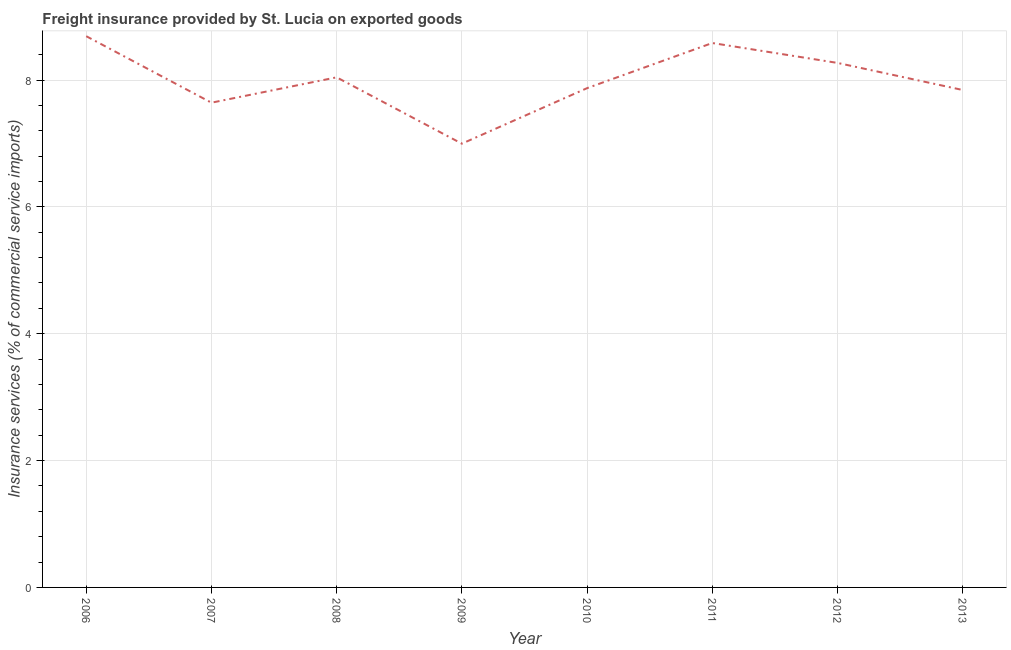What is the freight insurance in 2007?
Give a very brief answer. 7.64. Across all years, what is the maximum freight insurance?
Make the answer very short. 8.69. Across all years, what is the minimum freight insurance?
Your answer should be compact. 7. In which year was the freight insurance maximum?
Your answer should be very brief. 2006. What is the sum of the freight insurance?
Your answer should be very brief. 63.94. What is the difference between the freight insurance in 2006 and 2008?
Your answer should be compact. 0.65. What is the average freight insurance per year?
Give a very brief answer. 7.99. What is the median freight insurance?
Provide a short and direct response. 7.96. In how many years, is the freight insurance greater than 6.8 %?
Your response must be concise. 8. What is the ratio of the freight insurance in 2008 to that in 2013?
Your answer should be compact. 1.03. Is the difference between the freight insurance in 2010 and 2011 greater than the difference between any two years?
Make the answer very short. No. What is the difference between the highest and the second highest freight insurance?
Offer a very short reply. 0.11. Is the sum of the freight insurance in 2008 and 2009 greater than the maximum freight insurance across all years?
Your answer should be very brief. Yes. What is the difference between the highest and the lowest freight insurance?
Offer a terse response. 1.69. Does the freight insurance monotonically increase over the years?
Offer a very short reply. No. How many lines are there?
Provide a succinct answer. 1. How many years are there in the graph?
Your answer should be compact. 8. What is the title of the graph?
Make the answer very short. Freight insurance provided by St. Lucia on exported goods . What is the label or title of the X-axis?
Provide a succinct answer. Year. What is the label or title of the Y-axis?
Offer a terse response. Insurance services (% of commercial service imports). What is the Insurance services (% of commercial service imports) of 2006?
Provide a succinct answer. 8.69. What is the Insurance services (% of commercial service imports) in 2007?
Provide a succinct answer. 7.64. What is the Insurance services (% of commercial service imports) of 2008?
Ensure brevity in your answer.  8.04. What is the Insurance services (% of commercial service imports) in 2009?
Provide a succinct answer. 7. What is the Insurance services (% of commercial service imports) in 2010?
Ensure brevity in your answer.  7.87. What is the Insurance services (% of commercial service imports) of 2011?
Offer a terse response. 8.58. What is the Insurance services (% of commercial service imports) in 2012?
Make the answer very short. 8.27. What is the Insurance services (% of commercial service imports) in 2013?
Keep it short and to the point. 7.84. What is the difference between the Insurance services (% of commercial service imports) in 2006 and 2007?
Give a very brief answer. 1.05. What is the difference between the Insurance services (% of commercial service imports) in 2006 and 2008?
Offer a very short reply. 0.65. What is the difference between the Insurance services (% of commercial service imports) in 2006 and 2009?
Your answer should be compact. 1.69. What is the difference between the Insurance services (% of commercial service imports) in 2006 and 2010?
Provide a succinct answer. 0.82. What is the difference between the Insurance services (% of commercial service imports) in 2006 and 2011?
Keep it short and to the point. 0.11. What is the difference between the Insurance services (% of commercial service imports) in 2006 and 2012?
Your answer should be very brief. 0.42. What is the difference between the Insurance services (% of commercial service imports) in 2006 and 2013?
Ensure brevity in your answer.  0.85. What is the difference between the Insurance services (% of commercial service imports) in 2007 and 2008?
Your answer should be compact. -0.4. What is the difference between the Insurance services (% of commercial service imports) in 2007 and 2009?
Provide a short and direct response. 0.65. What is the difference between the Insurance services (% of commercial service imports) in 2007 and 2010?
Offer a terse response. -0.23. What is the difference between the Insurance services (% of commercial service imports) in 2007 and 2011?
Your response must be concise. -0.94. What is the difference between the Insurance services (% of commercial service imports) in 2007 and 2012?
Your response must be concise. -0.63. What is the difference between the Insurance services (% of commercial service imports) in 2007 and 2013?
Offer a very short reply. -0.2. What is the difference between the Insurance services (% of commercial service imports) in 2008 and 2009?
Give a very brief answer. 1.05. What is the difference between the Insurance services (% of commercial service imports) in 2008 and 2010?
Offer a very short reply. 0.17. What is the difference between the Insurance services (% of commercial service imports) in 2008 and 2011?
Offer a very short reply. -0.54. What is the difference between the Insurance services (% of commercial service imports) in 2008 and 2012?
Keep it short and to the point. -0.23. What is the difference between the Insurance services (% of commercial service imports) in 2008 and 2013?
Offer a very short reply. 0.2. What is the difference between the Insurance services (% of commercial service imports) in 2009 and 2010?
Offer a terse response. -0.88. What is the difference between the Insurance services (% of commercial service imports) in 2009 and 2011?
Provide a short and direct response. -1.59. What is the difference between the Insurance services (% of commercial service imports) in 2009 and 2012?
Provide a succinct answer. -1.27. What is the difference between the Insurance services (% of commercial service imports) in 2009 and 2013?
Your answer should be very brief. -0.85. What is the difference between the Insurance services (% of commercial service imports) in 2010 and 2011?
Provide a short and direct response. -0.71. What is the difference between the Insurance services (% of commercial service imports) in 2010 and 2012?
Make the answer very short. -0.4. What is the difference between the Insurance services (% of commercial service imports) in 2010 and 2013?
Provide a succinct answer. 0.03. What is the difference between the Insurance services (% of commercial service imports) in 2011 and 2012?
Ensure brevity in your answer.  0.31. What is the difference between the Insurance services (% of commercial service imports) in 2011 and 2013?
Provide a succinct answer. 0.74. What is the difference between the Insurance services (% of commercial service imports) in 2012 and 2013?
Your answer should be very brief. 0.43. What is the ratio of the Insurance services (% of commercial service imports) in 2006 to that in 2007?
Provide a short and direct response. 1.14. What is the ratio of the Insurance services (% of commercial service imports) in 2006 to that in 2008?
Keep it short and to the point. 1.08. What is the ratio of the Insurance services (% of commercial service imports) in 2006 to that in 2009?
Make the answer very short. 1.24. What is the ratio of the Insurance services (% of commercial service imports) in 2006 to that in 2010?
Keep it short and to the point. 1.1. What is the ratio of the Insurance services (% of commercial service imports) in 2006 to that in 2011?
Keep it short and to the point. 1.01. What is the ratio of the Insurance services (% of commercial service imports) in 2006 to that in 2012?
Ensure brevity in your answer.  1.05. What is the ratio of the Insurance services (% of commercial service imports) in 2006 to that in 2013?
Make the answer very short. 1.11. What is the ratio of the Insurance services (% of commercial service imports) in 2007 to that in 2008?
Give a very brief answer. 0.95. What is the ratio of the Insurance services (% of commercial service imports) in 2007 to that in 2009?
Your answer should be very brief. 1.09. What is the ratio of the Insurance services (% of commercial service imports) in 2007 to that in 2010?
Ensure brevity in your answer.  0.97. What is the ratio of the Insurance services (% of commercial service imports) in 2007 to that in 2011?
Your answer should be very brief. 0.89. What is the ratio of the Insurance services (% of commercial service imports) in 2007 to that in 2012?
Provide a short and direct response. 0.92. What is the ratio of the Insurance services (% of commercial service imports) in 2008 to that in 2009?
Offer a terse response. 1.15. What is the ratio of the Insurance services (% of commercial service imports) in 2008 to that in 2011?
Your response must be concise. 0.94. What is the ratio of the Insurance services (% of commercial service imports) in 2009 to that in 2010?
Your answer should be very brief. 0.89. What is the ratio of the Insurance services (% of commercial service imports) in 2009 to that in 2011?
Give a very brief answer. 0.81. What is the ratio of the Insurance services (% of commercial service imports) in 2009 to that in 2012?
Give a very brief answer. 0.85. What is the ratio of the Insurance services (% of commercial service imports) in 2009 to that in 2013?
Ensure brevity in your answer.  0.89. What is the ratio of the Insurance services (% of commercial service imports) in 2010 to that in 2011?
Provide a succinct answer. 0.92. What is the ratio of the Insurance services (% of commercial service imports) in 2010 to that in 2013?
Provide a succinct answer. 1. What is the ratio of the Insurance services (% of commercial service imports) in 2011 to that in 2012?
Offer a terse response. 1.04. What is the ratio of the Insurance services (% of commercial service imports) in 2011 to that in 2013?
Offer a terse response. 1.09. What is the ratio of the Insurance services (% of commercial service imports) in 2012 to that in 2013?
Your answer should be very brief. 1.05. 